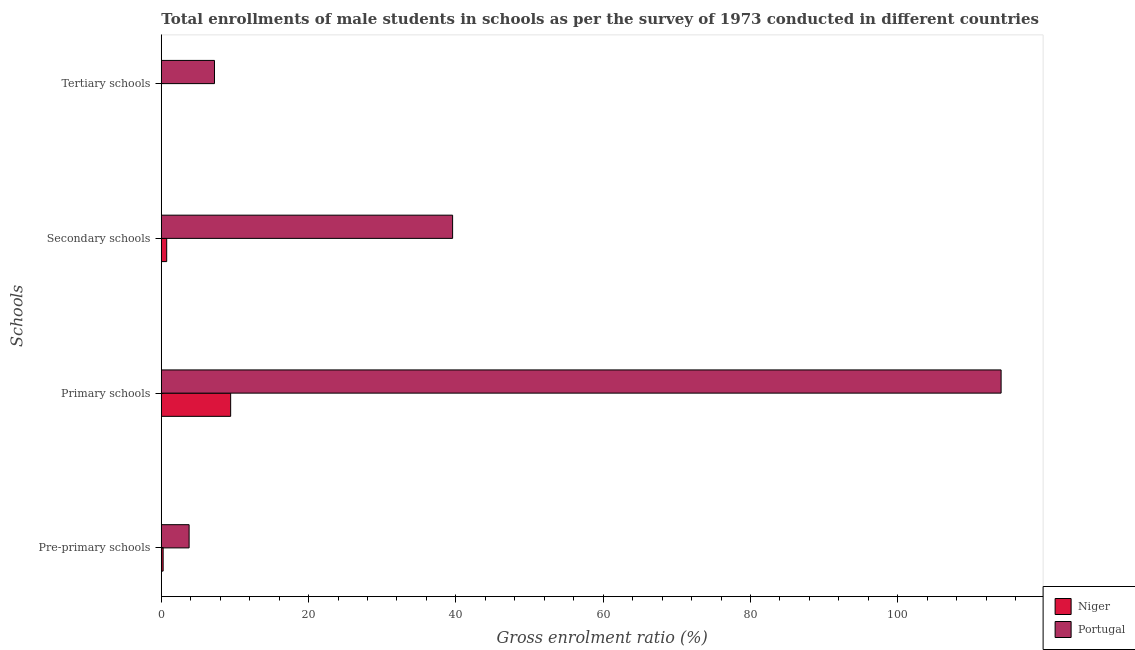How many different coloured bars are there?
Offer a very short reply. 2. Are the number of bars per tick equal to the number of legend labels?
Give a very brief answer. Yes. Are the number of bars on each tick of the Y-axis equal?
Offer a very short reply. Yes. What is the label of the 3rd group of bars from the top?
Provide a succinct answer. Primary schools. What is the gross enrolment ratio(male) in secondary schools in Portugal?
Your answer should be very brief. 39.55. Across all countries, what is the maximum gross enrolment ratio(male) in secondary schools?
Ensure brevity in your answer.  39.55. Across all countries, what is the minimum gross enrolment ratio(male) in tertiary schools?
Your answer should be compact. 0.01. In which country was the gross enrolment ratio(male) in primary schools maximum?
Keep it short and to the point. Portugal. In which country was the gross enrolment ratio(male) in pre-primary schools minimum?
Your response must be concise. Niger. What is the total gross enrolment ratio(male) in primary schools in the graph?
Offer a terse response. 123.45. What is the difference between the gross enrolment ratio(male) in primary schools in Portugal and that in Niger?
Your response must be concise. 104.62. What is the difference between the gross enrolment ratio(male) in pre-primary schools in Portugal and the gross enrolment ratio(male) in primary schools in Niger?
Ensure brevity in your answer.  -5.64. What is the average gross enrolment ratio(male) in secondary schools per country?
Provide a short and direct response. 20.14. What is the difference between the gross enrolment ratio(male) in primary schools and gross enrolment ratio(male) in tertiary schools in Niger?
Your answer should be very brief. 9.41. In how many countries, is the gross enrolment ratio(male) in primary schools greater than 72 %?
Offer a terse response. 1. What is the ratio of the gross enrolment ratio(male) in secondary schools in Portugal to that in Niger?
Provide a succinct answer. 54.05. Is the gross enrolment ratio(male) in primary schools in Niger less than that in Portugal?
Provide a short and direct response. Yes. Is the difference between the gross enrolment ratio(male) in secondary schools in Portugal and Niger greater than the difference between the gross enrolment ratio(male) in primary schools in Portugal and Niger?
Your response must be concise. No. What is the difference between the highest and the second highest gross enrolment ratio(male) in secondary schools?
Your response must be concise. 38.82. What is the difference between the highest and the lowest gross enrolment ratio(male) in tertiary schools?
Your answer should be very brief. 7.21. Is it the case that in every country, the sum of the gross enrolment ratio(male) in pre-primary schools and gross enrolment ratio(male) in tertiary schools is greater than the sum of gross enrolment ratio(male) in secondary schools and gross enrolment ratio(male) in primary schools?
Make the answer very short. No. What does the 2nd bar from the top in Secondary schools represents?
Offer a terse response. Niger. What does the 1st bar from the bottom in Primary schools represents?
Offer a very short reply. Niger. Are the values on the major ticks of X-axis written in scientific E-notation?
Your response must be concise. No. Does the graph contain any zero values?
Your answer should be compact. No. Where does the legend appear in the graph?
Your response must be concise. Bottom right. What is the title of the graph?
Keep it short and to the point. Total enrollments of male students in schools as per the survey of 1973 conducted in different countries. What is the label or title of the X-axis?
Offer a terse response. Gross enrolment ratio (%). What is the label or title of the Y-axis?
Give a very brief answer. Schools. What is the Gross enrolment ratio (%) in Niger in Pre-primary schools?
Your response must be concise. 0.25. What is the Gross enrolment ratio (%) in Portugal in Pre-primary schools?
Offer a terse response. 3.77. What is the Gross enrolment ratio (%) in Niger in Primary schools?
Give a very brief answer. 9.41. What is the Gross enrolment ratio (%) of Portugal in Primary schools?
Your response must be concise. 114.03. What is the Gross enrolment ratio (%) of Niger in Secondary schools?
Offer a very short reply. 0.73. What is the Gross enrolment ratio (%) in Portugal in Secondary schools?
Make the answer very short. 39.55. What is the Gross enrolment ratio (%) in Niger in Tertiary schools?
Provide a short and direct response. 0.01. What is the Gross enrolment ratio (%) of Portugal in Tertiary schools?
Provide a succinct answer. 7.22. Across all Schools, what is the maximum Gross enrolment ratio (%) of Niger?
Give a very brief answer. 9.41. Across all Schools, what is the maximum Gross enrolment ratio (%) of Portugal?
Your answer should be compact. 114.03. Across all Schools, what is the minimum Gross enrolment ratio (%) in Niger?
Your answer should be very brief. 0.01. Across all Schools, what is the minimum Gross enrolment ratio (%) in Portugal?
Make the answer very short. 3.77. What is the total Gross enrolment ratio (%) of Niger in the graph?
Ensure brevity in your answer.  10.4. What is the total Gross enrolment ratio (%) of Portugal in the graph?
Make the answer very short. 164.58. What is the difference between the Gross enrolment ratio (%) in Niger in Pre-primary schools and that in Primary schools?
Your answer should be very brief. -9.17. What is the difference between the Gross enrolment ratio (%) of Portugal in Pre-primary schools and that in Primary schools?
Your answer should be compact. -110.26. What is the difference between the Gross enrolment ratio (%) in Niger in Pre-primary schools and that in Secondary schools?
Your response must be concise. -0.48. What is the difference between the Gross enrolment ratio (%) of Portugal in Pre-primary schools and that in Secondary schools?
Your answer should be compact. -35.78. What is the difference between the Gross enrolment ratio (%) of Niger in Pre-primary schools and that in Tertiary schools?
Offer a very short reply. 0.24. What is the difference between the Gross enrolment ratio (%) in Portugal in Pre-primary schools and that in Tertiary schools?
Your answer should be compact. -3.45. What is the difference between the Gross enrolment ratio (%) of Niger in Primary schools and that in Secondary schools?
Offer a very short reply. 8.68. What is the difference between the Gross enrolment ratio (%) of Portugal in Primary schools and that in Secondary schools?
Offer a terse response. 74.48. What is the difference between the Gross enrolment ratio (%) in Niger in Primary schools and that in Tertiary schools?
Your response must be concise. 9.41. What is the difference between the Gross enrolment ratio (%) of Portugal in Primary schools and that in Tertiary schools?
Provide a succinct answer. 106.81. What is the difference between the Gross enrolment ratio (%) in Niger in Secondary schools and that in Tertiary schools?
Your response must be concise. 0.73. What is the difference between the Gross enrolment ratio (%) in Portugal in Secondary schools and that in Tertiary schools?
Your answer should be very brief. 32.33. What is the difference between the Gross enrolment ratio (%) of Niger in Pre-primary schools and the Gross enrolment ratio (%) of Portugal in Primary schools?
Offer a terse response. -113.78. What is the difference between the Gross enrolment ratio (%) in Niger in Pre-primary schools and the Gross enrolment ratio (%) in Portugal in Secondary schools?
Offer a terse response. -39.3. What is the difference between the Gross enrolment ratio (%) in Niger in Pre-primary schools and the Gross enrolment ratio (%) in Portugal in Tertiary schools?
Your response must be concise. -6.97. What is the difference between the Gross enrolment ratio (%) of Niger in Primary schools and the Gross enrolment ratio (%) of Portugal in Secondary schools?
Provide a succinct answer. -30.14. What is the difference between the Gross enrolment ratio (%) of Niger in Primary schools and the Gross enrolment ratio (%) of Portugal in Tertiary schools?
Offer a very short reply. 2.19. What is the difference between the Gross enrolment ratio (%) in Niger in Secondary schools and the Gross enrolment ratio (%) in Portugal in Tertiary schools?
Keep it short and to the point. -6.49. What is the average Gross enrolment ratio (%) of Niger per Schools?
Make the answer very short. 2.6. What is the average Gross enrolment ratio (%) of Portugal per Schools?
Offer a terse response. 41.14. What is the difference between the Gross enrolment ratio (%) in Niger and Gross enrolment ratio (%) in Portugal in Pre-primary schools?
Give a very brief answer. -3.53. What is the difference between the Gross enrolment ratio (%) in Niger and Gross enrolment ratio (%) in Portugal in Primary schools?
Offer a terse response. -104.62. What is the difference between the Gross enrolment ratio (%) in Niger and Gross enrolment ratio (%) in Portugal in Secondary schools?
Give a very brief answer. -38.82. What is the difference between the Gross enrolment ratio (%) of Niger and Gross enrolment ratio (%) of Portugal in Tertiary schools?
Give a very brief answer. -7.21. What is the ratio of the Gross enrolment ratio (%) of Niger in Pre-primary schools to that in Primary schools?
Offer a terse response. 0.03. What is the ratio of the Gross enrolment ratio (%) of Portugal in Pre-primary schools to that in Primary schools?
Make the answer very short. 0.03. What is the ratio of the Gross enrolment ratio (%) of Niger in Pre-primary schools to that in Secondary schools?
Provide a short and direct response. 0.34. What is the ratio of the Gross enrolment ratio (%) of Portugal in Pre-primary schools to that in Secondary schools?
Make the answer very short. 0.1. What is the ratio of the Gross enrolment ratio (%) of Niger in Pre-primary schools to that in Tertiary schools?
Keep it short and to the point. 47.32. What is the ratio of the Gross enrolment ratio (%) in Portugal in Pre-primary schools to that in Tertiary schools?
Ensure brevity in your answer.  0.52. What is the ratio of the Gross enrolment ratio (%) of Niger in Primary schools to that in Secondary schools?
Your response must be concise. 12.87. What is the ratio of the Gross enrolment ratio (%) of Portugal in Primary schools to that in Secondary schools?
Offer a very short reply. 2.88. What is the ratio of the Gross enrolment ratio (%) in Niger in Primary schools to that in Tertiary schools?
Offer a very short reply. 1796.66. What is the ratio of the Gross enrolment ratio (%) of Portugal in Primary schools to that in Tertiary schools?
Offer a very short reply. 15.79. What is the ratio of the Gross enrolment ratio (%) in Niger in Secondary schools to that in Tertiary schools?
Offer a very short reply. 139.65. What is the ratio of the Gross enrolment ratio (%) of Portugal in Secondary schools to that in Tertiary schools?
Provide a succinct answer. 5.48. What is the difference between the highest and the second highest Gross enrolment ratio (%) in Niger?
Provide a succinct answer. 8.68. What is the difference between the highest and the second highest Gross enrolment ratio (%) of Portugal?
Ensure brevity in your answer.  74.48. What is the difference between the highest and the lowest Gross enrolment ratio (%) of Niger?
Provide a succinct answer. 9.41. What is the difference between the highest and the lowest Gross enrolment ratio (%) in Portugal?
Offer a terse response. 110.26. 